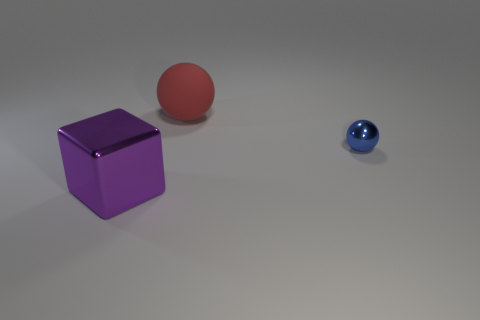Is there anything else that is the same size as the blue thing?
Offer a very short reply. No. Is there any other thing that has the same material as the red sphere?
Offer a terse response. No. What is the shape of the big object that is made of the same material as the blue ball?
Give a very brief answer. Cube. What size is the object that is made of the same material as the large purple block?
Provide a succinct answer. Small. Is there a large metallic thing?
Your answer should be very brief. Yes. There is a sphere right of the big object on the right side of the big thing that is to the left of the large ball; how big is it?
Your response must be concise. Small. What number of red objects are the same material as the big red ball?
Provide a short and direct response. 0. What number of red matte spheres have the same size as the rubber thing?
Your response must be concise. 0. What material is the object that is on the right side of the sphere on the left side of the metal object on the right side of the purple cube?
Ensure brevity in your answer.  Metal. How many things are either tiny yellow blocks or blocks?
Offer a terse response. 1. 